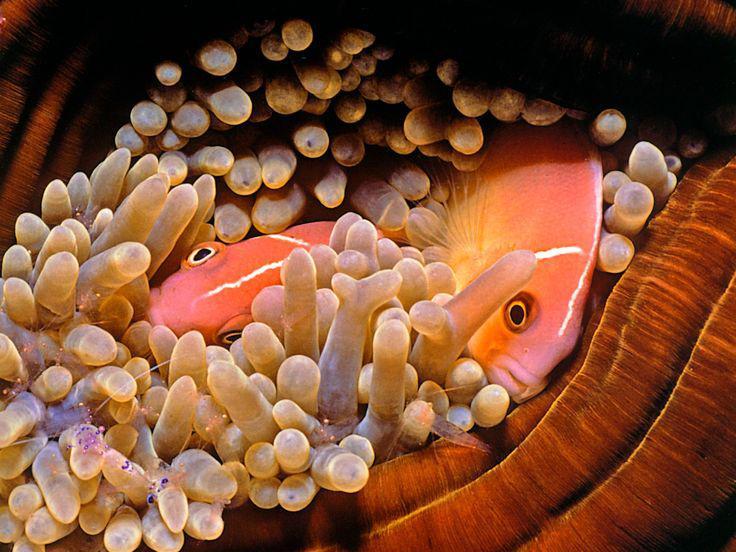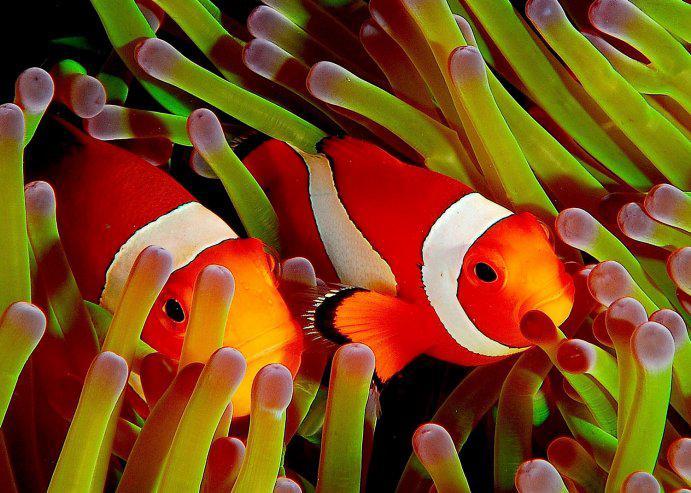The first image is the image on the left, the second image is the image on the right. Examine the images to the left and right. Is the description "There are exactly two clownfish in the right image." accurate? Answer yes or no. Yes. The first image is the image on the left, the second image is the image on the right. For the images displayed, is the sentence "One image shows two fish in anemone tendrils that emerge from a dark-orangish """"stalk""""." factually correct? Answer yes or no. Yes. 